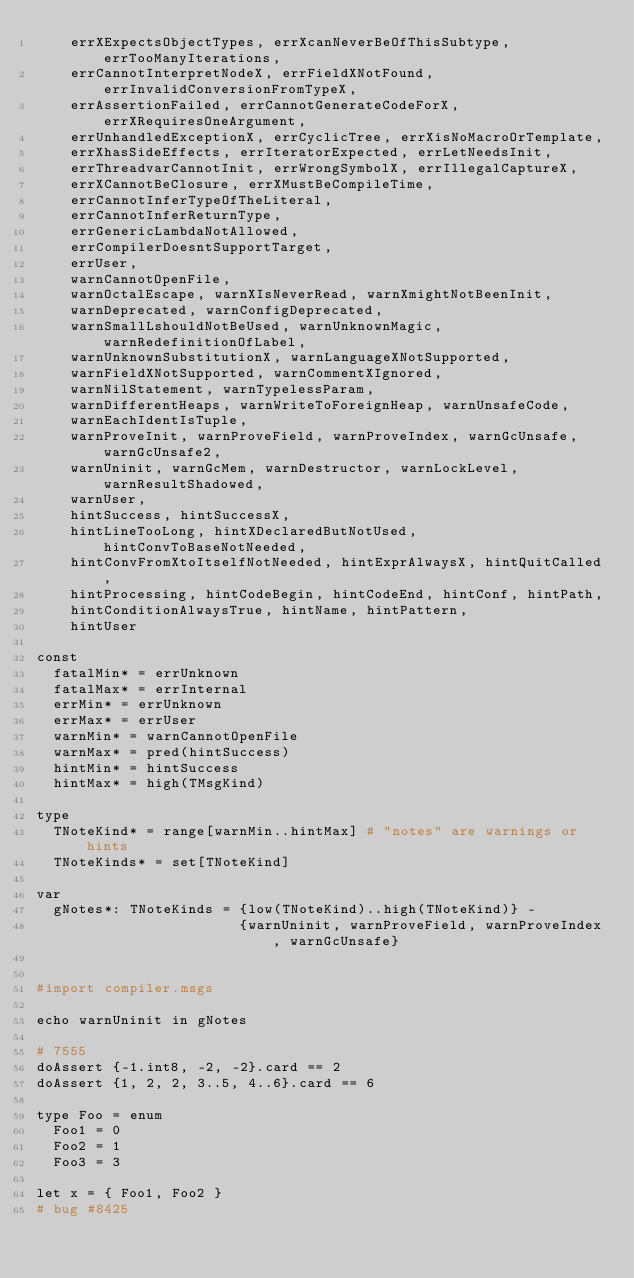<code> <loc_0><loc_0><loc_500><loc_500><_Nim_>    errXExpectsObjectTypes, errXcanNeverBeOfThisSubtype, errTooManyIterations,
    errCannotInterpretNodeX, errFieldXNotFound, errInvalidConversionFromTypeX,
    errAssertionFailed, errCannotGenerateCodeForX, errXRequiresOneArgument,
    errUnhandledExceptionX, errCyclicTree, errXisNoMacroOrTemplate,
    errXhasSideEffects, errIteratorExpected, errLetNeedsInit,
    errThreadvarCannotInit, errWrongSymbolX, errIllegalCaptureX,
    errXCannotBeClosure, errXMustBeCompileTime,
    errCannotInferTypeOfTheLiteral,
    errCannotInferReturnType,
    errGenericLambdaNotAllowed,
    errCompilerDoesntSupportTarget,
    errUser,
    warnCannotOpenFile,
    warnOctalEscape, warnXIsNeverRead, warnXmightNotBeenInit,
    warnDeprecated, warnConfigDeprecated,
    warnSmallLshouldNotBeUsed, warnUnknownMagic, warnRedefinitionOfLabel,
    warnUnknownSubstitutionX, warnLanguageXNotSupported,
    warnFieldXNotSupported, warnCommentXIgnored,
    warnNilStatement, warnTypelessParam,
    warnDifferentHeaps, warnWriteToForeignHeap, warnUnsafeCode,
    warnEachIdentIsTuple,
    warnProveInit, warnProveField, warnProveIndex, warnGcUnsafe, warnGcUnsafe2,
    warnUninit, warnGcMem, warnDestructor, warnLockLevel, warnResultShadowed,
    warnUser,
    hintSuccess, hintSuccessX,
    hintLineTooLong, hintXDeclaredButNotUsed, hintConvToBaseNotNeeded,
    hintConvFromXtoItselfNotNeeded, hintExprAlwaysX, hintQuitCalled,
    hintProcessing, hintCodeBegin, hintCodeEnd, hintConf, hintPath,
    hintConditionAlwaysTrue, hintName, hintPattern,
    hintUser

const
  fatalMin* = errUnknown
  fatalMax* = errInternal
  errMin* = errUnknown
  errMax* = errUser
  warnMin* = warnCannotOpenFile
  warnMax* = pred(hintSuccess)
  hintMin* = hintSuccess
  hintMax* = high(TMsgKind)

type
  TNoteKind* = range[warnMin..hintMax] # "notes" are warnings or hints
  TNoteKinds* = set[TNoteKind]

var
  gNotes*: TNoteKinds = {low(TNoteKind)..high(TNoteKind)} -
                        {warnUninit, warnProveField, warnProveIndex, warnGcUnsafe}


#import compiler.msgs

echo warnUninit in gNotes

# 7555
doAssert {-1.int8, -2, -2}.card == 2
doAssert {1, 2, 2, 3..5, 4..6}.card == 6

type Foo = enum
  Foo1 = 0
  Foo2 = 1
  Foo3 = 3

let x = { Foo1, Foo2 }
# bug #8425
</code> 